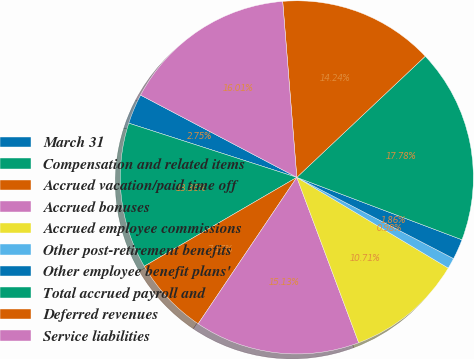<chart> <loc_0><loc_0><loc_500><loc_500><pie_chart><fcel>March 31<fcel>Compensation and related items<fcel>Accrued vacation/paid time off<fcel>Accrued bonuses<fcel>Accrued employee commissions<fcel>Other post-retirement benefits<fcel>Other employee benefit plans'<fcel>Total accrued payroll and<fcel>Deferred revenues<fcel>Service liabilities<nl><fcel>2.75%<fcel>13.36%<fcel>7.17%<fcel>15.13%<fcel>10.71%<fcel>0.98%<fcel>1.86%<fcel>17.78%<fcel>14.24%<fcel>16.01%<nl></chart> 